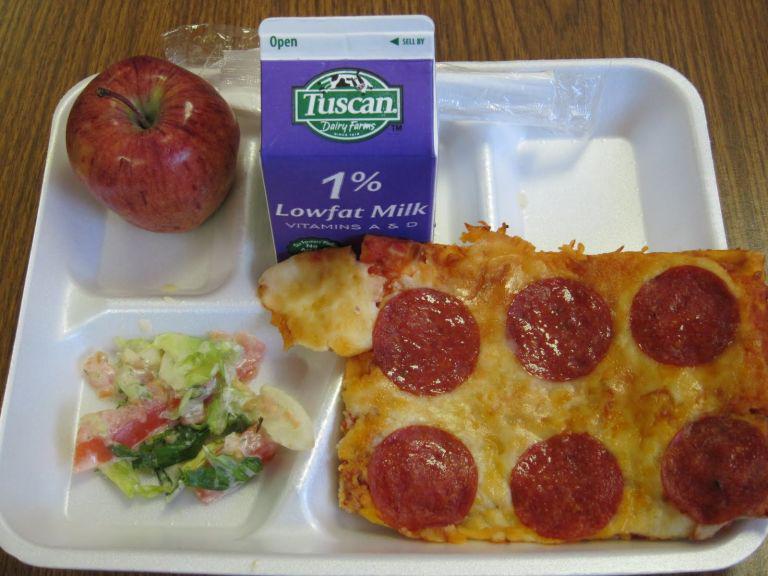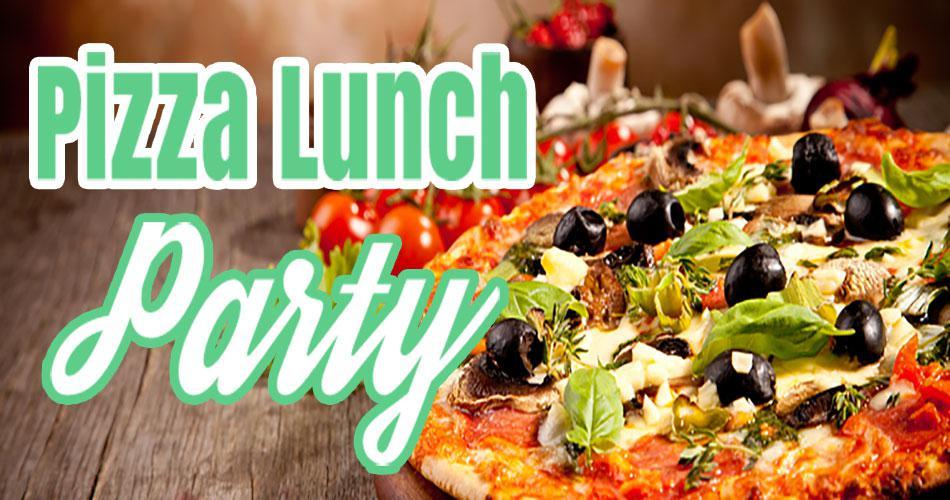The first image is the image on the left, the second image is the image on the right. For the images displayed, is the sentence "One image features a single round pizza that is not cut into slices, and the other image features one pepperoni pizza cut into wedge-shaped slices." factually correct? Answer yes or no. No. The first image is the image on the left, the second image is the image on the right. Given the left and right images, does the statement "One of the pizzas has onion on it." hold true? Answer yes or no. No. 